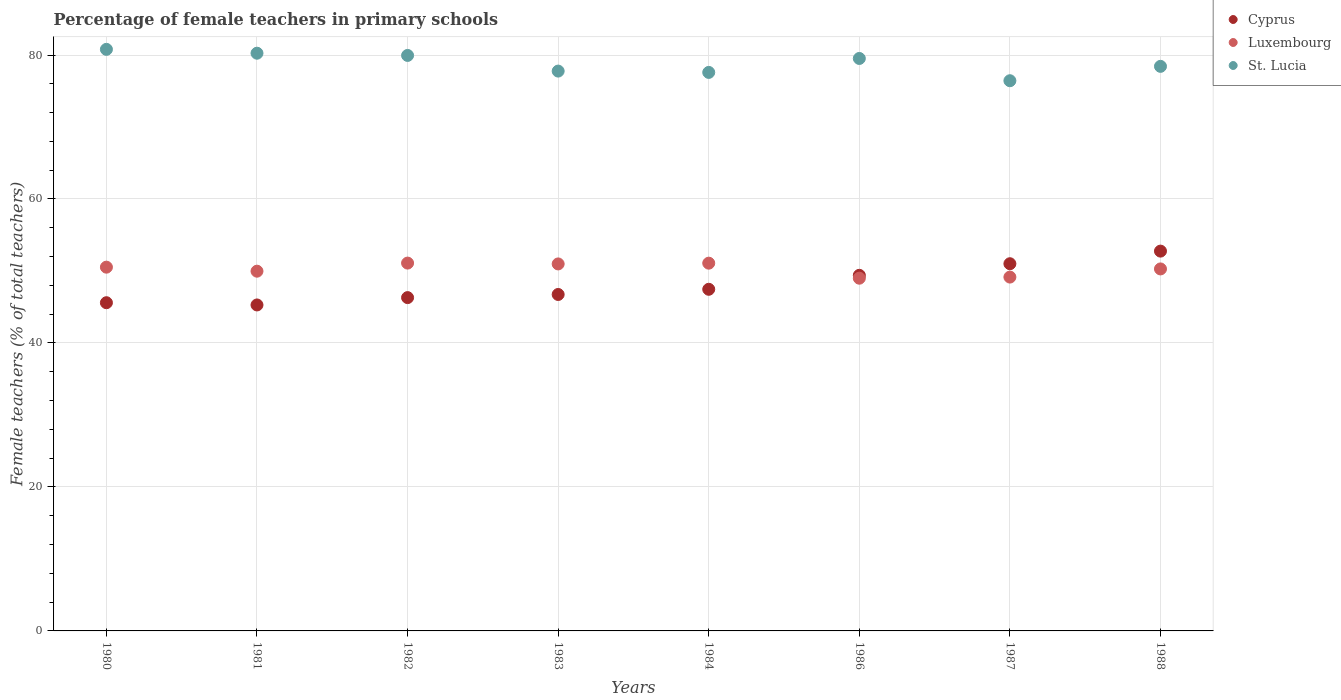How many different coloured dotlines are there?
Give a very brief answer. 3. What is the percentage of female teachers in St. Lucia in 1981?
Ensure brevity in your answer.  80.25. Across all years, what is the maximum percentage of female teachers in Cyprus?
Keep it short and to the point. 52.76. Across all years, what is the minimum percentage of female teachers in St. Lucia?
Offer a terse response. 76.43. In which year was the percentage of female teachers in St. Lucia minimum?
Your answer should be compact. 1987. What is the total percentage of female teachers in Luxembourg in the graph?
Give a very brief answer. 402.09. What is the difference between the percentage of female teachers in St. Lucia in 1987 and that in 1988?
Keep it short and to the point. -2. What is the difference between the percentage of female teachers in St. Lucia in 1986 and the percentage of female teachers in Cyprus in 1980?
Your answer should be very brief. 33.93. What is the average percentage of female teachers in St. Lucia per year?
Offer a very short reply. 78.84. In the year 1980, what is the difference between the percentage of female teachers in Luxembourg and percentage of female teachers in Cyprus?
Give a very brief answer. 4.94. In how many years, is the percentage of female teachers in St. Lucia greater than 20 %?
Your response must be concise. 8. What is the ratio of the percentage of female teachers in Luxembourg in 1987 to that in 1988?
Your response must be concise. 0.98. Is the difference between the percentage of female teachers in Luxembourg in 1987 and 1988 greater than the difference between the percentage of female teachers in Cyprus in 1987 and 1988?
Give a very brief answer. Yes. What is the difference between the highest and the second highest percentage of female teachers in St. Lucia?
Ensure brevity in your answer.  0.53. What is the difference between the highest and the lowest percentage of female teachers in St. Lucia?
Your answer should be very brief. 4.36. In how many years, is the percentage of female teachers in St. Lucia greater than the average percentage of female teachers in St. Lucia taken over all years?
Give a very brief answer. 4. Is the sum of the percentage of female teachers in Luxembourg in 1983 and 1984 greater than the maximum percentage of female teachers in St. Lucia across all years?
Ensure brevity in your answer.  Yes. Does the percentage of female teachers in St. Lucia monotonically increase over the years?
Give a very brief answer. No. How many dotlines are there?
Give a very brief answer. 3. How many years are there in the graph?
Give a very brief answer. 8. How many legend labels are there?
Your answer should be compact. 3. How are the legend labels stacked?
Offer a terse response. Vertical. What is the title of the graph?
Your response must be concise. Percentage of female teachers in primary schools. What is the label or title of the X-axis?
Your answer should be very brief. Years. What is the label or title of the Y-axis?
Ensure brevity in your answer.  Female teachers (% of total teachers). What is the Female teachers (% of total teachers) of Cyprus in 1980?
Keep it short and to the point. 45.59. What is the Female teachers (% of total teachers) of Luxembourg in 1980?
Offer a very short reply. 50.53. What is the Female teachers (% of total teachers) in St. Lucia in 1980?
Offer a very short reply. 80.79. What is the Female teachers (% of total teachers) in Cyprus in 1981?
Provide a succinct answer. 45.28. What is the Female teachers (% of total teachers) in Luxembourg in 1981?
Offer a terse response. 49.97. What is the Female teachers (% of total teachers) in St. Lucia in 1981?
Your response must be concise. 80.25. What is the Female teachers (% of total teachers) in Cyprus in 1982?
Your response must be concise. 46.3. What is the Female teachers (% of total teachers) of Luxembourg in 1982?
Your response must be concise. 51.1. What is the Female teachers (% of total teachers) of St. Lucia in 1982?
Your answer should be compact. 79.94. What is the Female teachers (% of total teachers) in Cyprus in 1983?
Make the answer very short. 46.74. What is the Female teachers (% of total teachers) of Luxembourg in 1983?
Provide a short and direct response. 50.98. What is the Female teachers (% of total teachers) of St. Lucia in 1983?
Offer a terse response. 77.77. What is the Female teachers (% of total teachers) in Cyprus in 1984?
Offer a very short reply. 47.46. What is the Female teachers (% of total teachers) in Luxembourg in 1984?
Your response must be concise. 51.08. What is the Female teachers (% of total teachers) of St. Lucia in 1984?
Your response must be concise. 77.58. What is the Female teachers (% of total teachers) of Cyprus in 1986?
Your answer should be compact. 49.4. What is the Female teachers (% of total teachers) in Luxembourg in 1986?
Your answer should be compact. 49. What is the Female teachers (% of total teachers) of St. Lucia in 1986?
Offer a terse response. 79.52. What is the Female teachers (% of total teachers) in Cyprus in 1987?
Provide a short and direct response. 51.01. What is the Female teachers (% of total teachers) of Luxembourg in 1987?
Your answer should be very brief. 49.15. What is the Female teachers (% of total teachers) of St. Lucia in 1987?
Provide a succinct answer. 76.43. What is the Female teachers (% of total teachers) in Cyprus in 1988?
Your answer should be very brief. 52.76. What is the Female teachers (% of total teachers) in Luxembourg in 1988?
Your answer should be very brief. 50.28. What is the Female teachers (% of total teachers) of St. Lucia in 1988?
Provide a succinct answer. 78.42. Across all years, what is the maximum Female teachers (% of total teachers) of Cyprus?
Keep it short and to the point. 52.76. Across all years, what is the maximum Female teachers (% of total teachers) of Luxembourg?
Provide a short and direct response. 51.1. Across all years, what is the maximum Female teachers (% of total teachers) in St. Lucia?
Your response must be concise. 80.79. Across all years, what is the minimum Female teachers (% of total teachers) of Cyprus?
Ensure brevity in your answer.  45.28. Across all years, what is the minimum Female teachers (% of total teachers) in Luxembourg?
Your response must be concise. 49. Across all years, what is the minimum Female teachers (% of total teachers) in St. Lucia?
Offer a terse response. 76.43. What is the total Female teachers (% of total teachers) of Cyprus in the graph?
Your answer should be very brief. 384.53. What is the total Female teachers (% of total teachers) in Luxembourg in the graph?
Keep it short and to the point. 402.09. What is the total Female teachers (% of total teachers) of St. Lucia in the graph?
Provide a short and direct response. 630.7. What is the difference between the Female teachers (% of total teachers) of Cyprus in 1980 and that in 1981?
Give a very brief answer. 0.31. What is the difference between the Female teachers (% of total teachers) of Luxembourg in 1980 and that in 1981?
Your answer should be compact. 0.56. What is the difference between the Female teachers (% of total teachers) in St. Lucia in 1980 and that in 1981?
Offer a very short reply. 0.53. What is the difference between the Female teachers (% of total teachers) of Cyprus in 1980 and that in 1982?
Give a very brief answer. -0.71. What is the difference between the Female teachers (% of total teachers) in Luxembourg in 1980 and that in 1982?
Ensure brevity in your answer.  -0.57. What is the difference between the Female teachers (% of total teachers) of St. Lucia in 1980 and that in 1982?
Ensure brevity in your answer.  0.84. What is the difference between the Female teachers (% of total teachers) of Cyprus in 1980 and that in 1983?
Offer a very short reply. -1.14. What is the difference between the Female teachers (% of total teachers) in Luxembourg in 1980 and that in 1983?
Provide a short and direct response. -0.45. What is the difference between the Female teachers (% of total teachers) in St. Lucia in 1980 and that in 1983?
Give a very brief answer. 3.02. What is the difference between the Female teachers (% of total teachers) in Cyprus in 1980 and that in 1984?
Provide a short and direct response. -1.87. What is the difference between the Female teachers (% of total teachers) in Luxembourg in 1980 and that in 1984?
Ensure brevity in your answer.  -0.56. What is the difference between the Female teachers (% of total teachers) in St. Lucia in 1980 and that in 1984?
Offer a terse response. 3.2. What is the difference between the Female teachers (% of total teachers) in Cyprus in 1980 and that in 1986?
Your answer should be very brief. -3.81. What is the difference between the Female teachers (% of total teachers) in Luxembourg in 1980 and that in 1986?
Your answer should be compact. 1.53. What is the difference between the Female teachers (% of total teachers) of St. Lucia in 1980 and that in 1986?
Offer a very short reply. 1.27. What is the difference between the Female teachers (% of total teachers) in Cyprus in 1980 and that in 1987?
Your response must be concise. -5.42. What is the difference between the Female teachers (% of total teachers) in Luxembourg in 1980 and that in 1987?
Provide a succinct answer. 1.38. What is the difference between the Female teachers (% of total teachers) of St. Lucia in 1980 and that in 1987?
Offer a terse response. 4.36. What is the difference between the Female teachers (% of total teachers) in Cyprus in 1980 and that in 1988?
Your response must be concise. -7.17. What is the difference between the Female teachers (% of total teachers) in Luxembourg in 1980 and that in 1988?
Your response must be concise. 0.25. What is the difference between the Female teachers (% of total teachers) of St. Lucia in 1980 and that in 1988?
Your answer should be very brief. 2.36. What is the difference between the Female teachers (% of total teachers) of Cyprus in 1981 and that in 1982?
Provide a short and direct response. -1.02. What is the difference between the Female teachers (% of total teachers) of Luxembourg in 1981 and that in 1982?
Provide a succinct answer. -1.12. What is the difference between the Female teachers (% of total teachers) of St. Lucia in 1981 and that in 1982?
Provide a succinct answer. 0.31. What is the difference between the Female teachers (% of total teachers) in Cyprus in 1981 and that in 1983?
Make the answer very short. -1.46. What is the difference between the Female teachers (% of total teachers) of Luxembourg in 1981 and that in 1983?
Your answer should be compact. -1.01. What is the difference between the Female teachers (% of total teachers) of St. Lucia in 1981 and that in 1983?
Ensure brevity in your answer.  2.48. What is the difference between the Female teachers (% of total teachers) of Cyprus in 1981 and that in 1984?
Offer a very short reply. -2.18. What is the difference between the Female teachers (% of total teachers) of Luxembourg in 1981 and that in 1984?
Offer a terse response. -1.11. What is the difference between the Female teachers (% of total teachers) of St. Lucia in 1981 and that in 1984?
Provide a succinct answer. 2.67. What is the difference between the Female teachers (% of total teachers) of Cyprus in 1981 and that in 1986?
Provide a short and direct response. -4.12. What is the difference between the Female teachers (% of total teachers) in Luxembourg in 1981 and that in 1986?
Provide a succinct answer. 0.97. What is the difference between the Female teachers (% of total teachers) of St. Lucia in 1981 and that in 1986?
Offer a very short reply. 0.73. What is the difference between the Female teachers (% of total teachers) in Cyprus in 1981 and that in 1987?
Your answer should be compact. -5.73. What is the difference between the Female teachers (% of total teachers) in Luxembourg in 1981 and that in 1987?
Give a very brief answer. 0.82. What is the difference between the Female teachers (% of total teachers) of St. Lucia in 1981 and that in 1987?
Ensure brevity in your answer.  3.82. What is the difference between the Female teachers (% of total teachers) in Cyprus in 1981 and that in 1988?
Ensure brevity in your answer.  -7.48. What is the difference between the Female teachers (% of total teachers) in Luxembourg in 1981 and that in 1988?
Give a very brief answer. -0.31. What is the difference between the Female teachers (% of total teachers) of St. Lucia in 1981 and that in 1988?
Your answer should be very brief. 1.83. What is the difference between the Female teachers (% of total teachers) of Cyprus in 1982 and that in 1983?
Your answer should be very brief. -0.44. What is the difference between the Female teachers (% of total teachers) of Luxembourg in 1982 and that in 1983?
Your response must be concise. 0.12. What is the difference between the Female teachers (% of total teachers) of St. Lucia in 1982 and that in 1983?
Provide a short and direct response. 2.17. What is the difference between the Female teachers (% of total teachers) in Cyprus in 1982 and that in 1984?
Your response must be concise. -1.16. What is the difference between the Female teachers (% of total teachers) in Luxembourg in 1982 and that in 1984?
Provide a short and direct response. 0.01. What is the difference between the Female teachers (% of total teachers) of St. Lucia in 1982 and that in 1984?
Ensure brevity in your answer.  2.36. What is the difference between the Female teachers (% of total teachers) in Cyprus in 1982 and that in 1986?
Your answer should be very brief. -3.1. What is the difference between the Female teachers (% of total teachers) of Luxembourg in 1982 and that in 1986?
Your response must be concise. 2.1. What is the difference between the Female teachers (% of total teachers) in St. Lucia in 1982 and that in 1986?
Ensure brevity in your answer.  0.42. What is the difference between the Female teachers (% of total teachers) in Cyprus in 1982 and that in 1987?
Offer a terse response. -4.71. What is the difference between the Female teachers (% of total teachers) of Luxembourg in 1982 and that in 1987?
Your answer should be compact. 1.94. What is the difference between the Female teachers (% of total teachers) in St. Lucia in 1982 and that in 1987?
Offer a very short reply. 3.51. What is the difference between the Female teachers (% of total teachers) in Cyprus in 1982 and that in 1988?
Your answer should be compact. -6.46. What is the difference between the Female teachers (% of total teachers) of Luxembourg in 1982 and that in 1988?
Ensure brevity in your answer.  0.81. What is the difference between the Female teachers (% of total teachers) in St. Lucia in 1982 and that in 1988?
Ensure brevity in your answer.  1.52. What is the difference between the Female teachers (% of total teachers) of Cyprus in 1983 and that in 1984?
Keep it short and to the point. -0.72. What is the difference between the Female teachers (% of total teachers) in Luxembourg in 1983 and that in 1984?
Provide a succinct answer. -0.11. What is the difference between the Female teachers (% of total teachers) in St. Lucia in 1983 and that in 1984?
Provide a short and direct response. 0.18. What is the difference between the Female teachers (% of total teachers) of Cyprus in 1983 and that in 1986?
Provide a succinct answer. -2.66. What is the difference between the Female teachers (% of total teachers) of Luxembourg in 1983 and that in 1986?
Your response must be concise. 1.98. What is the difference between the Female teachers (% of total teachers) in St. Lucia in 1983 and that in 1986?
Provide a short and direct response. -1.75. What is the difference between the Female teachers (% of total teachers) in Cyprus in 1983 and that in 1987?
Offer a terse response. -4.27. What is the difference between the Female teachers (% of total teachers) of Luxembourg in 1983 and that in 1987?
Offer a very short reply. 1.83. What is the difference between the Female teachers (% of total teachers) of St. Lucia in 1983 and that in 1987?
Give a very brief answer. 1.34. What is the difference between the Female teachers (% of total teachers) of Cyprus in 1983 and that in 1988?
Your response must be concise. -6.02. What is the difference between the Female teachers (% of total teachers) in Luxembourg in 1983 and that in 1988?
Your response must be concise. 0.7. What is the difference between the Female teachers (% of total teachers) of St. Lucia in 1983 and that in 1988?
Your answer should be very brief. -0.66. What is the difference between the Female teachers (% of total teachers) of Cyprus in 1984 and that in 1986?
Make the answer very short. -1.94. What is the difference between the Female teachers (% of total teachers) of Luxembourg in 1984 and that in 1986?
Make the answer very short. 2.09. What is the difference between the Female teachers (% of total teachers) of St. Lucia in 1984 and that in 1986?
Offer a very short reply. -1.94. What is the difference between the Female teachers (% of total teachers) in Cyprus in 1984 and that in 1987?
Offer a terse response. -3.55. What is the difference between the Female teachers (% of total teachers) of Luxembourg in 1984 and that in 1987?
Your answer should be compact. 1.93. What is the difference between the Female teachers (% of total teachers) in St. Lucia in 1984 and that in 1987?
Provide a short and direct response. 1.16. What is the difference between the Female teachers (% of total teachers) of Cyprus in 1984 and that in 1988?
Give a very brief answer. -5.3. What is the difference between the Female teachers (% of total teachers) in Luxembourg in 1984 and that in 1988?
Provide a succinct answer. 0.8. What is the difference between the Female teachers (% of total teachers) of St. Lucia in 1984 and that in 1988?
Make the answer very short. -0.84. What is the difference between the Female teachers (% of total teachers) in Cyprus in 1986 and that in 1987?
Offer a terse response. -1.61. What is the difference between the Female teachers (% of total teachers) of Luxembourg in 1986 and that in 1987?
Your response must be concise. -0.15. What is the difference between the Female teachers (% of total teachers) of St. Lucia in 1986 and that in 1987?
Your answer should be very brief. 3.09. What is the difference between the Female teachers (% of total teachers) of Cyprus in 1986 and that in 1988?
Your answer should be very brief. -3.36. What is the difference between the Female teachers (% of total teachers) of Luxembourg in 1986 and that in 1988?
Make the answer very short. -1.29. What is the difference between the Female teachers (% of total teachers) of St. Lucia in 1986 and that in 1988?
Make the answer very short. 1.1. What is the difference between the Female teachers (% of total teachers) in Cyprus in 1987 and that in 1988?
Your response must be concise. -1.75. What is the difference between the Female teachers (% of total teachers) in Luxembourg in 1987 and that in 1988?
Provide a succinct answer. -1.13. What is the difference between the Female teachers (% of total teachers) of St. Lucia in 1987 and that in 1988?
Ensure brevity in your answer.  -2. What is the difference between the Female teachers (% of total teachers) of Cyprus in 1980 and the Female teachers (% of total teachers) of Luxembourg in 1981?
Your answer should be compact. -4.38. What is the difference between the Female teachers (% of total teachers) of Cyprus in 1980 and the Female teachers (% of total teachers) of St. Lucia in 1981?
Your answer should be very brief. -34.66. What is the difference between the Female teachers (% of total teachers) of Luxembourg in 1980 and the Female teachers (% of total teachers) of St. Lucia in 1981?
Your answer should be very brief. -29.72. What is the difference between the Female teachers (% of total teachers) in Cyprus in 1980 and the Female teachers (% of total teachers) in Luxembourg in 1982?
Offer a very short reply. -5.5. What is the difference between the Female teachers (% of total teachers) in Cyprus in 1980 and the Female teachers (% of total teachers) in St. Lucia in 1982?
Provide a short and direct response. -34.35. What is the difference between the Female teachers (% of total teachers) of Luxembourg in 1980 and the Female teachers (% of total teachers) of St. Lucia in 1982?
Offer a terse response. -29.41. What is the difference between the Female teachers (% of total teachers) in Cyprus in 1980 and the Female teachers (% of total teachers) in Luxembourg in 1983?
Ensure brevity in your answer.  -5.39. What is the difference between the Female teachers (% of total teachers) of Cyprus in 1980 and the Female teachers (% of total teachers) of St. Lucia in 1983?
Your answer should be very brief. -32.18. What is the difference between the Female teachers (% of total teachers) in Luxembourg in 1980 and the Female teachers (% of total teachers) in St. Lucia in 1983?
Keep it short and to the point. -27.24. What is the difference between the Female teachers (% of total teachers) of Cyprus in 1980 and the Female teachers (% of total teachers) of Luxembourg in 1984?
Make the answer very short. -5.49. What is the difference between the Female teachers (% of total teachers) of Cyprus in 1980 and the Female teachers (% of total teachers) of St. Lucia in 1984?
Your answer should be compact. -31.99. What is the difference between the Female teachers (% of total teachers) of Luxembourg in 1980 and the Female teachers (% of total teachers) of St. Lucia in 1984?
Offer a terse response. -27.05. What is the difference between the Female teachers (% of total teachers) of Cyprus in 1980 and the Female teachers (% of total teachers) of Luxembourg in 1986?
Your answer should be compact. -3.41. What is the difference between the Female teachers (% of total teachers) of Cyprus in 1980 and the Female teachers (% of total teachers) of St. Lucia in 1986?
Ensure brevity in your answer.  -33.93. What is the difference between the Female teachers (% of total teachers) of Luxembourg in 1980 and the Female teachers (% of total teachers) of St. Lucia in 1986?
Offer a very short reply. -28.99. What is the difference between the Female teachers (% of total teachers) in Cyprus in 1980 and the Female teachers (% of total teachers) in Luxembourg in 1987?
Your answer should be very brief. -3.56. What is the difference between the Female teachers (% of total teachers) in Cyprus in 1980 and the Female teachers (% of total teachers) in St. Lucia in 1987?
Provide a succinct answer. -30.84. What is the difference between the Female teachers (% of total teachers) of Luxembourg in 1980 and the Female teachers (% of total teachers) of St. Lucia in 1987?
Offer a terse response. -25.9. What is the difference between the Female teachers (% of total teachers) in Cyprus in 1980 and the Female teachers (% of total teachers) in Luxembourg in 1988?
Your answer should be compact. -4.69. What is the difference between the Female teachers (% of total teachers) of Cyprus in 1980 and the Female teachers (% of total teachers) of St. Lucia in 1988?
Your response must be concise. -32.83. What is the difference between the Female teachers (% of total teachers) of Luxembourg in 1980 and the Female teachers (% of total teachers) of St. Lucia in 1988?
Provide a short and direct response. -27.89. What is the difference between the Female teachers (% of total teachers) in Cyprus in 1981 and the Female teachers (% of total teachers) in Luxembourg in 1982?
Provide a succinct answer. -5.82. What is the difference between the Female teachers (% of total teachers) in Cyprus in 1981 and the Female teachers (% of total teachers) in St. Lucia in 1982?
Offer a very short reply. -34.66. What is the difference between the Female teachers (% of total teachers) of Luxembourg in 1981 and the Female teachers (% of total teachers) of St. Lucia in 1982?
Offer a terse response. -29.97. What is the difference between the Female teachers (% of total teachers) in Cyprus in 1981 and the Female teachers (% of total teachers) in Luxembourg in 1983?
Ensure brevity in your answer.  -5.7. What is the difference between the Female teachers (% of total teachers) of Cyprus in 1981 and the Female teachers (% of total teachers) of St. Lucia in 1983?
Keep it short and to the point. -32.49. What is the difference between the Female teachers (% of total teachers) in Luxembourg in 1981 and the Female teachers (% of total teachers) in St. Lucia in 1983?
Your response must be concise. -27.79. What is the difference between the Female teachers (% of total teachers) in Cyprus in 1981 and the Female teachers (% of total teachers) in Luxembourg in 1984?
Give a very brief answer. -5.8. What is the difference between the Female teachers (% of total teachers) in Cyprus in 1981 and the Female teachers (% of total teachers) in St. Lucia in 1984?
Offer a very short reply. -32.3. What is the difference between the Female teachers (% of total teachers) of Luxembourg in 1981 and the Female teachers (% of total teachers) of St. Lucia in 1984?
Your answer should be very brief. -27.61. What is the difference between the Female teachers (% of total teachers) of Cyprus in 1981 and the Female teachers (% of total teachers) of Luxembourg in 1986?
Keep it short and to the point. -3.72. What is the difference between the Female teachers (% of total teachers) of Cyprus in 1981 and the Female teachers (% of total teachers) of St. Lucia in 1986?
Your answer should be very brief. -34.24. What is the difference between the Female teachers (% of total teachers) of Luxembourg in 1981 and the Female teachers (% of total teachers) of St. Lucia in 1986?
Keep it short and to the point. -29.55. What is the difference between the Female teachers (% of total teachers) in Cyprus in 1981 and the Female teachers (% of total teachers) in Luxembourg in 1987?
Keep it short and to the point. -3.87. What is the difference between the Female teachers (% of total teachers) of Cyprus in 1981 and the Female teachers (% of total teachers) of St. Lucia in 1987?
Keep it short and to the point. -31.15. What is the difference between the Female teachers (% of total teachers) in Luxembourg in 1981 and the Female teachers (% of total teachers) in St. Lucia in 1987?
Your response must be concise. -26.46. What is the difference between the Female teachers (% of total teachers) in Cyprus in 1981 and the Female teachers (% of total teachers) in Luxembourg in 1988?
Your answer should be very brief. -5. What is the difference between the Female teachers (% of total teachers) of Cyprus in 1981 and the Female teachers (% of total teachers) of St. Lucia in 1988?
Give a very brief answer. -33.14. What is the difference between the Female teachers (% of total teachers) in Luxembourg in 1981 and the Female teachers (% of total teachers) in St. Lucia in 1988?
Your answer should be compact. -28.45. What is the difference between the Female teachers (% of total teachers) in Cyprus in 1982 and the Female teachers (% of total teachers) in Luxembourg in 1983?
Your answer should be compact. -4.68. What is the difference between the Female teachers (% of total teachers) of Cyprus in 1982 and the Female teachers (% of total teachers) of St. Lucia in 1983?
Give a very brief answer. -31.47. What is the difference between the Female teachers (% of total teachers) in Luxembourg in 1982 and the Female teachers (% of total teachers) in St. Lucia in 1983?
Give a very brief answer. -26.67. What is the difference between the Female teachers (% of total teachers) of Cyprus in 1982 and the Female teachers (% of total teachers) of Luxembourg in 1984?
Keep it short and to the point. -4.78. What is the difference between the Female teachers (% of total teachers) of Cyprus in 1982 and the Female teachers (% of total teachers) of St. Lucia in 1984?
Your answer should be compact. -31.28. What is the difference between the Female teachers (% of total teachers) in Luxembourg in 1982 and the Female teachers (% of total teachers) in St. Lucia in 1984?
Offer a terse response. -26.49. What is the difference between the Female teachers (% of total teachers) of Cyprus in 1982 and the Female teachers (% of total teachers) of Luxembourg in 1986?
Offer a very short reply. -2.7. What is the difference between the Female teachers (% of total teachers) of Cyprus in 1982 and the Female teachers (% of total teachers) of St. Lucia in 1986?
Your answer should be compact. -33.22. What is the difference between the Female teachers (% of total teachers) in Luxembourg in 1982 and the Female teachers (% of total teachers) in St. Lucia in 1986?
Your answer should be very brief. -28.42. What is the difference between the Female teachers (% of total teachers) of Cyprus in 1982 and the Female teachers (% of total teachers) of Luxembourg in 1987?
Offer a very short reply. -2.85. What is the difference between the Female teachers (% of total teachers) in Cyprus in 1982 and the Female teachers (% of total teachers) in St. Lucia in 1987?
Your answer should be very brief. -30.13. What is the difference between the Female teachers (% of total teachers) in Luxembourg in 1982 and the Female teachers (% of total teachers) in St. Lucia in 1987?
Your response must be concise. -25.33. What is the difference between the Female teachers (% of total teachers) in Cyprus in 1982 and the Female teachers (% of total teachers) in Luxembourg in 1988?
Give a very brief answer. -3.98. What is the difference between the Female teachers (% of total teachers) of Cyprus in 1982 and the Female teachers (% of total teachers) of St. Lucia in 1988?
Provide a short and direct response. -32.12. What is the difference between the Female teachers (% of total teachers) in Luxembourg in 1982 and the Female teachers (% of total teachers) in St. Lucia in 1988?
Provide a succinct answer. -27.33. What is the difference between the Female teachers (% of total teachers) of Cyprus in 1983 and the Female teachers (% of total teachers) of Luxembourg in 1984?
Your response must be concise. -4.35. What is the difference between the Female teachers (% of total teachers) of Cyprus in 1983 and the Female teachers (% of total teachers) of St. Lucia in 1984?
Give a very brief answer. -30.85. What is the difference between the Female teachers (% of total teachers) in Luxembourg in 1983 and the Female teachers (% of total teachers) in St. Lucia in 1984?
Offer a very short reply. -26.6. What is the difference between the Female teachers (% of total teachers) in Cyprus in 1983 and the Female teachers (% of total teachers) in Luxembourg in 1986?
Keep it short and to the point. -2.26. What is the difference between the Female teachers (% of total teachers) in Cyprus in 1983 and the Female teachers (% of total teachers) in St. Lucia in 1986?
Provide a short and direct response. -32.78. What is the difference between the Female teachers (% of total teachers) in Luxembourg in 1983 and the Female teachers (% of total teachers) in St. Lucia in 1986?
Give a very brief answer. -28.54. What is the difference between the Female teachers (% of total teachers) of Cyprus in 1983 and the Female teachers (% of total teachers) of Luxembourg in 1987?
Ensure brevity in your answer.  -2.42. What is the difference between the Female teachers (% of total teachers) of Cyprus in 1983 and the Female teachers (% of total teachers) of St. Lucia in 1987?
Provide a short and direct response. -29.69. What is the difference between the Female teachers (% of total teachers) in Luxembourg in 1983 and the Female teachers (% of total teachers) in St. Lucia in 1987?
Your answer should be compact. -25.45. What is the difference between the Female teachers (% of total teachers) of Cyprus in 1983 and the Female teachers (% of total teachers) of Luxembourg in 1988?
Provide a succinct answer. -3.55. What is the difference between the Female teachers (% of total teachers) of Cyprus in 1983 and the Female teachers (% of total teachers) of St. Lucia in 1988?
Give a very brief answer. -31.69. What is the difference between the Female teachers (% of total teachers) of Luxembourg in 1983 and the Female teachers (% of total teachers) of St. Lucia in 1988?
Keep it short and to the point. -27.44. What is the difference between the Female teachers (% of total teachers) in Cyprus in 1984 and the Female teachers (% of total teachers) in Luxembourg in 1986?
Your response must be concise. -1.54. What is the difference between the Female teachers (% of total teachers) in Cyprus in 1984 and the Female teachers (% of total teachers) in St. Lucia in 1986?
Keep it short and to the point. -32.06. What is the difference between the Female teachers (% of total teachers) in Luxembourg in 1984 and the Female teachers (% of total teachers) in St. Lucia in 1986?
Keep it short and to the point. -28.44. What is the difference between the Female teachers (% of total teachers) in Cyprus in 1984 and the Female teachers (% of total teachers) in Luxembourg in 1987?
Offer a terse response. -1.7. What is the difference between the Female teachers (% of total teachers) of Cyprus in 1984 and the Female teachers (% of total teachers) of St. Lucia in 1987?
Provide a short and direct response. -28.97. What is the difference between the Female teachers (% of total teachers) of Luxembourg in 1984 and the Female teachers (% of total teachers) of St. Lucia in 1987?
Make the answer very short. -25.34. What is the difference between the Female teachers (% of total teachers) of Cyprus in 1984 and the Female teachers (% of total teachers) of Luxembourg in 1988?
Your answer should be very brief. -2.83. What is the difference between the Female teachers (% of total teachers) in Cyprus in 1984 and the Female teachers (% of total teachers) in St. Lucia in 1988?
Your response must be concise. -30.97. What is the difference between the Female teachers (% of total teachers) of Luxembourg in 1984 and the Female teachers (% of total teachers) of St. Lucia in 1988?
Your answer should be compact. -27.34. What is the difference between the Female teachers (% of total teachers) in Cyprus in 1986 and the Female teachers (% of total teachers) in Luxembourg in 1987?
Your answer should be compact. 0.25. What is the difference between the Female teachers (% of total teachers) in Cyprus in 1986 and the Female teachers (% of total teachers) in St. Lucia in 1987?
Ensure brevity in your answer.  -27.03. What is the difference between the Female teachers (% of total teachers) in Luxembourg in 1986 and the Female teachers (% of total teachers) in St. Lucia in 1987?
Keep it short and to the point. -27.43. What is the difference between the Female teachers (% of total teachers) of Cyprus in 1986 and the Female teachers (% of total teachers) of Luxembourg in 1988?
Provide a short and direct response. -0.89. What is the difference between the Female teachers (% of total teachers) of Cyprus in 1986 and the Female teachers (% of total teachers) of St. Lucia in 1988?
Your response must be concise. -29.03. What is the difference between the Female teachers (% of total teachers) of Luxembourg in 1986 and the Female teachers (% of total teachers) of St. Lucia in 1988?
Make the answer very short. -29.43. What is the difference between the Female teachers (% of total teachers) of Cyprus in 1987 and the Female teachers (% of total teachers) of Luxembourg in 1988?
Provide a succinct answer. 0.72. What is the difference between the Female teachers (% of total teachers) of Cyprus in 1987 and the Female teachers (% of total teachers) of St. Lucia in 1988?
Offer a terse response. -27.42. What is the difference between the Female teachers (% of total teachers) of Luxembourg in 1987 and the Female teachers (% of total teachers) of St. Lucia in 1988?
Provide a short and direct response. -29.27. What is the average Female teachers (% of total teachers) of Cyprus per year?
Your answer should be very brief. 48.07. What is the average Female teachers (% of total teachers) of Luxembourg per year?
Make the answer very short. 50.26. What is the average Female teachers (% of total teachers) of St. Lucia per year?
Your answer should be very brief. 78.84. In the year 1980, what is the difference between the Female teachers (% of total teachers) of Cyprus and Female teachers (% of total teachers) of Luxembourg?
Provide a succinct answer. -4.94. In the year 1980, what is the difference between the Female teachers (% of total teachers) in Cyprus and Female teachers (% of total teachers) in St. Lucia?
Your answer should be compact. -35.19. In the year 1980, what is the difference between the Female teachers (% of total teachers) of Luxembourg and Female teachers (% of total teachers) of St. Lucia?
Give a very brief answer. -30.26. In the year 1981, what is the difference between the Female teachers (% of total teachers) of Cyprus and Female teachers (% of total teachers) of Luxembourg?
Keep it short and to the point. -4.69. In the year 1981, what is the difference between the Female teachers (% of total teachers) in Cyprus and Female teachers (% of total teachers) in St. Lucia?
Your answer should be compact. -34.97. In the year 1981, what is the difference between the Female teachers (% of total teachers) in Luxembourg and Female teachers (% of total teachers) in St. Lucia?
Your answer should be very brief. -30.28. In the year 1982, what is the difference between the Female teachers (% of total teachers) of Cyprus and Female teachers (% of total teachers) of Luxembourg?
Offer a terse response. -4.8. In the year 1982, what is the difference between the Female teachers (% of total teachers) in Cyprus and Female teachers (% of total teachers) in St. Lucia?
Your answer should be compact. -33.64. In the year 1982, what is the difference between the Female teachers (% of total teachers) of Luxembourg and Female teachers (% of total teachers) of St. Lucia?
Provide a succinct answer. -28.84. In the year 1983, what is the difference between the Female teachers (% of total teachers) of Cyprus and Female teachers (% of total teachers) of Luxembourg?
Provide a short and direct response. -4.24. In the year 1983, what is the difference between the Female teachers (% of total teachers) in Cyprus and Female teachers (% of total teachers) in St. Lucia?
Your response must be concise. -31.03. In the year 1983, what is the difference between the Female teachers (% of total teachers) in Luxembourg and Female teachers (% of total teachers) in St. Lucia?
Offer a terse response. -26.79. In the year 1984, what is the difference between the Female teachers (% of total teachers) in Cyprus and Female teachers (% of total teachers) in Luxembourg?
Offer a very short reply. -3.63. In the year 1984, what is the difference between the Female teachers (% of total teachers) in Cyprus and Female teachers (% of total teachers) in St. Lucia?
Your response must be concise. -30.13. In the year 1984, what is the difference between the Female teachers (% of total teachers) of Luxembourg and Female teachers (% of total teachers) of St. Lucia?
Offer a terse response. -26.5. In the year 1986, what is the difference between the Female teachers (% of total teachers) of Cyprus and Female teachers (% of total teachers) of Luxembourg?
Make the answer very short. 0.4. In the year 1986, what is the difference between the Female teachers (% of total teachers) in Cyprus and Female teachers (% of total teachers) in St. Lucia?
Your response must be concise. -30.12. In the year 1986, what is the difference between the Female teachers (% of total teachers) in Luxembourg and Female teachers (% of total teachers) in St. Lucia?
Offer a very short reply. -30.52. In the year 1987, what is the difference between the Female teachers (% of total teachers) in Cyprus and Female teachers (% of total teachers) in Luxembourg?
Your answer should be compact. 1.86. In the year 1987, what is the difference between the Female teachers (% of total teachers) in Cyprus and Female teachers (% of total teachers) in St. Lucia?
Your response must be concise. -25.42. In the year 1987, what is the difference between the Female teachers (% of total teachers) in Luxembourg and Female teachers (% of total teachers) in St. Lucia?
Provide a short and direct response. -27.28. In the year 1988, what is the difference between the Female teachers (% of total teachers) in Cyprus and Female teachers (% of total teachers) in Luxembourg?
Make the answer very short. 2.47. In the year 1988, what is the difference between the Female teachers (% of total teachers) in Cyprus and Female teachers (% of total teachers) in St. Lucia?
Your response must be concise. -25.67. In the year 1988, what is the difference between the Female teachers (% of total teachers) in Luxembourg and Female teachers (% of total teachers) in St. Lucia?
Your answer should be very brief. -28.14. What is the ratio of the Female teachers (% of total teachers) of Cyprus in 1980 to that in 1981?
Make the answer very short. 1.01. What is the ratio of the Female teachers (% of total teachers) in Luxembourg in 1980 to that in 1981?
Ensure brevity in your answer.  1.01. What is the ratio of the Female teachers (% of total teachers) in Cyprus in 1980 to that in 1982?
Your response must be concise. 0.98. What is the ratio of the Female teachers (% of total teachers) of Luxembourg in 1980 to that in 1982?
Make the answer very short. 0.99. What is the ratio of the Female teachers (% of total teachers) of St. Lucia in 1980 to that in 1982?
Ensure brevity in your answer.  1.01. What is the ratio of the Female teachers (% of total teachers) in Cyprus in 1980 to that in 1983?
Keep it short and to the point. 0.98. What is the ratio of the Female teachers (% of total teachers) of Luxembourg in 1980 to that in 1983?
Your answer should be very brief. 0.99. What is the ratio of the Female teachers (% of total teachers) in St. Lucia in 1980 to that in 1983?
Make the answer very short. 1.04. What is the ratio of the Female teachers (% of total teachers) of Cyprus in 1980 to that in 1984?
Your response must be concise. 0.96. What is the ratio of the Female teachers (% of total teachers) of St. Lucia in 1980 to that in 1984?
Your response must be concise. 1.04. What is the ratio of the Female teachers (% of total teachers) in Cyprus in 1980 to that in 1986?
Offer a very short reply. 0.92. What is the ratio of the Female teachers (% of total teachers) in Luxembourg in 1980 to that in 1986?
Make the answer very short. 1.03. What is the ratio of the Female teachers (% of total teachers) of St. Lucia in 1980 to that in 1986?
Offer a very short reply. 1.02. What is the ratio of the Female teachers (% of total teachers) in Cyprus in 1980 to that in 1987?
Your response must be concise. 0.89. What is the ratio of the Female teachers (% of total teachers) in Luxembourg in 1980 to that in 1987?
Provide a short and direct response. 1.03. What is the ratio of the Female teachers (% of total teachers) in St. Lucia in 1980 to that in 1987?
Your answer should be very brief. 1.06. What is the ratio of the Female teachers (% of total teachers) of Cyprus in 1980 to that in 1988?
Make the answer very short. 0.86. What is the ratio of the Female teachers (% of total teachers) in Luxembourg in 1980 to that in 1988?
Your answer should be compact. 1. What is the ratio of the Female teachers (% of total teachers) of St. Lucia in 1980 to that in 1988?
Your answer should be compact. 1.03. What is the ratio of the Female teachers (% of total teachers) of Luxembourg in 1981 to that in 1982?
Offer a terse response. 0.98. What is the ratio of the Female teachers (% of total teachers) of St. Lucia in 1981 to that in 1982?
Offer a very short reply. 1. What is the ratio of the Female teachers (% of total teachers) of Cyprus in 1981 to that in 1983?
Provide a succinct answer. 0.97. What is the ratio of the Female teachers (% of total teachers) of Luxembourg in 1981 to that in 1983?
Make the answer very short. 0.98. What is the ratio of the Female teachers (% of total teachers) in St. Lucia in 1981 to that in 1983?
Your response must be concise. 1.03. What is the ratio of the Female teachers (% of total teachers) in Cyprus in 1981 to that in 1984?
Give a very brief answer. 0.95. What is the ratio of the Female teachers (% of total teachers) of Luxembourg in 1981 to that in 1984?
Offer a terse response. 0.98. What is the ratio of the Female teachers (% of total teachers) of St. Lucia in 1981 to that in 1984?
Provide a short and direct response. 1.03. What is the ratio of the Female teachers (% of total teachers) in Cyprus in 1981 to that in 1986?
Provide a short and direct response. 0.92. What is the ratio of the Female teachers (% of total teachers) in Luxembourg in 1981 to that in 1986?
Provide a short and direct response. 1.02. What is the ratio of the Female teachers (% of total teachers) of St. Lucia in 1981 to that in 1986?
Ensure brevity in your answer.  1.01. What is the ratio of the Female teachers (% of total teachers) in Cyprus in 1981 to that in 1987?
Your response must be concise. 0.89. What is the ratio of the Female teachers (% of total teachers) in Luxembourg in 1981 to that in 1987?
Provide a short and direct response. 1.02. What is the ratio of the Female teachers (% of total teachers) in Cyprus in 1981 to that in 1988?
Your answer should be compact. 0.86. What is the ratio of the Female teachers (% of total teachers) of St. Lucia in 1981 to that in 1988?
Provide a succinct answer. 1.02. What is the ratio of the Female teachers (% of total teachers) in Cyprus in 1982 to that in 1983?
Your answer should be compact. 0.99. What is the ratio of the Female teachers (% of total teachers) in St. Lucia in 1982 to that in 1983?
Offer a very short reply. 1.03. What is the ratio of the Female teachers (% of total teachers) in Cyprus in 1982 to that in 1984?
Ensure brevity in your answer.  0.98. What is the ratio of the Female teachers (% of total teachers) of St. Lucia in 1982 to that in 1984?
Provide a short and direct response. 1.03. What is the ratio of the Female teachers (% of total teachers) in Cyprus in 1982 to that in 1986?
Provide a succinct answer. 0.94. What is the ratio of the Female teachers (% of total teachers) of Luxembourg in 1982 to that in 1986?
Provide a succinct answer. 1.04. What is the ratio of the Female teachers (% of total teachers) in Cyprus in 1982 to that in 1987?
Your answer should be very brief. 0.91. What is the ratio of the Female teachers (% of total teachers) of Luxembourg in 1982 to that in 1987?
Provide a succinct answer. 1.04. What is the ratio of the Female teachers (% of total teachers) of St. Lucia in 1982 to that in 1987?
Make the answer very short. 1.05. What is the ratio of the Female teachers (% of total teachers) of Cyprus in 1982 to that in 1988?
Provide a short and direct response. 0.88. What is the ratio of the Female teachers (% of total teachers) in Luxembourg in 1982 to that in 1988?
Offer a terse response. 1.02. What is the ratio of the Female teachers (% of total teachers) of St. Lucia in 1982 to that in 1988?
Offer a very short reply. 1.02. What is the ratio of the Female teachers (% of total teachers) of Luxembourg in 1983 to that in 1984?
Provide a succinct answer. 1. What is the ratio of the Female teachers (% of total teachers) in St. Lucia in 1983 to that in 1984?
Offer a terse response. 1. What is the ratio of the Female teachers (% of total teachers) in Cyprus in 1983 to that in 1986?
Provide a short and direct response. 0.95. What is the ratio of the Female teachers (% of total teachers) of Luxembourg in 1983 to that in 1986?
Provide a short and direct response. 1.04. What is the ratio of the Female teachers (% of total teachers) in St. Lucia in 1983 to that in 1986?
Make the answer very short. 0.98. What is the ratio of the Female teachers (% of total teachers) in Cyprus in 1983 to that in 1987?
Offer a very short reply. 0.92. What is the ratio of the Female teachers (% of total teachers) of Luxembourg in 1983 to that in 1987?
Offer a terse response. 1.04. What is the ratio of the Female teachers (% of total teachers) of St. Lucia in 1983 to that in 1987?
Provide a succinct answer. 1.02. What is the ratio of the Female teachers (% of total teachers) of Cyprus in 1983 to that in 1988?
Your answer should be very brief. 0.89. What is the ratio of the Female teachers (% of total teachers) in Luxembourg in 1983 to that in 1988?
Your response must be concise. 1.01. What is the ratio of the Female teachers (% of total teachers) of Cyprus in 1984 to that in 1986?
Keep it short and to the point. 0.96. What is the ratio of the Female teachers (% of total teachers) in Luxembourg in 1984 to that in 1986?
Ensure brevity in your answer.  1.04. What is the ratio of the Female teachers (% of total teachers) in St. Lucia in 1984 to that in 1986?
Offer a very short reply. 0.98. What is the ratio of the Female teachers (% of total teachers) of Cyprus in 1984 to that in 1987?
Give a very brief answer. 0.93. What is the ratio of the Female teachers (% of total teachers) of Luxembourg in 1984 to that in 1987?
Your answer should be compact. 1.04. What is the ratio of the Female teachers (% of total teachers) of St. Lucia in 1984 to that in 1987?
Your response must be concise. 1.02. What is the ratio of the Female teachers (% of total teachers) in Cyprus in 1984 to that in 1988?
Offer a very short reply. 0.9. What is the ratio of the Female teachers (% of total teachers) in Luxembourg in 1984 to that in 1988?
Your response must be concise. 1.02. What is the ratio of the Female teachers (% of total teachers) in St. Lucia in 1984 to that in 1988?
Your answer should be compact. 0.99. What is the ratio of the Female teachers (% of total teachers) of Cyprus in 1986 to that in 1987?
Your answer should be very brief. 0.97. What is the ratio of the Female teachers (% of total teachers) of St. Lucia in 1986 to that in 1987?
Provide a succinct answer. 1.04. What is the ratio of the Female teachers (% of total teachers) of Cyprus in 1986 to that in 1988?
Your answer should be compact. 0.94. What is the ratio of the Female teachers (% of total teachers) of Luxembourg in 1986 to that in 1988?
Provide a short and direct response. 0.97. What is the ratio of the Female teachers (% of total teachers) of Cyprus in 1987 to that in 1988?
Keep it short and to the point. 0.97. What is the ratio of the Female teachers (% of total teachers) of Luxembourg in 1987 to that in 1988?
Offer a very short reply. 0.98. What is the ratio of the Female teachers (% of total teachers) in St. Lucia in 1987 to that in 1988?
Offer a terse response. 0.97. What is the difference between the highest and the second highest Female teachers (% of total teachers) in Cyprus?
Provide a short and direct response. 1.75. What is the difference between the highest and the second highest Female teachers (% of total teachers) in Luxembourg?
Your answer should be compact. 0.01. What is the difference between the highest and the second highest Female teachers (% of total teachers) in St. Lucia?
Provide a succinct answer. 0.53. What is the difference between the highest and the lowest Female teachers (% of total teachers) in Cyprus?
Your answer should be very brief. 7.48. What is the difference between the highest and the lowest Female teachers (% of total teachers) in Luxembourg?
Keep it short and to the point. 2.1. What is the difference between the highest and the lowest Female teachers (% of total teachers) of St. Lucia?
Make the answer very short. 4.36. 